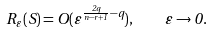Convert formula to latex. <formula><loc_0><loc_0><loc_500><loc_500>R _ { \varepsilon } ( S ) = O ( \varepsilon ^ { \frac { 2 q } { n - r + 1 } - q } ) , \quad \varepsilon \to 0 .</formula> 